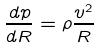Convert formula to latex. <formula><loc_0><loc_0><loc_500><loc_500>\frac { d p } { d R } = \rho \frac { v ^ { 2 } } { R }</formula> 